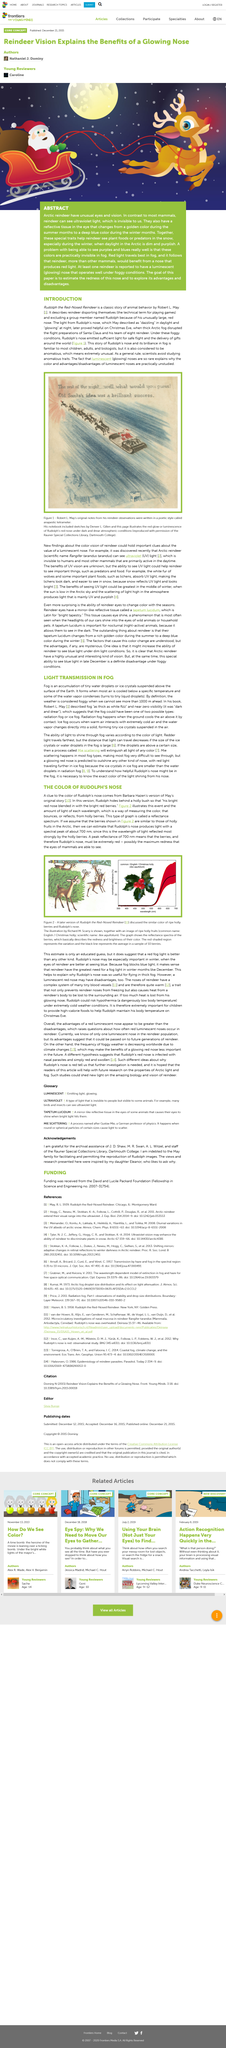Give some essential details in this illustration. Fog is the accumulation of tiny water droplets or ice crystals suspended above the surface of the Earth, as stated in the article "LIGHT TRANSMISSION IN FOG. The color of Rudolph's nose is red, and it is clearly stated in the given sentence. The picture depicts Santa's successful idea for the rest of the night, which was written brilliantly. Rudolph, hiding behind a holly bush, asked himself where he had placed his reindeer antlers. The story of Rudolph the Red-Nosed Reindeer, written by Robert L. May, is a classic example of animal behavior. 